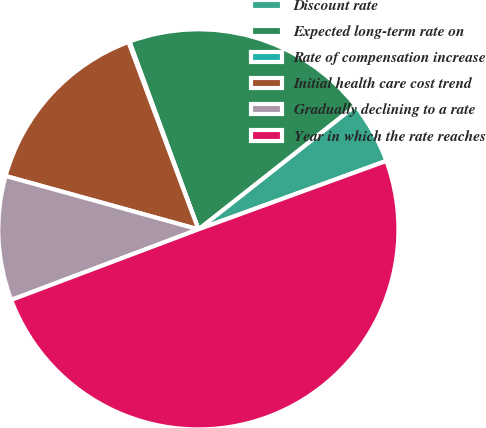Convert chart to OTSL. <chart><loc_0><loc_0><loc_500><loc_500><pie_chart><fcel>Discount rate<fcel>Expected long-term rate on<fcel>Rate of compensation increase<fcel>Initial health care cost trend<fcel>Gradually declining to a rate<fcel>Year in which the rate reaches<nl><fcel>5.06%<fcel>19.98%<fcel>0.09%<fcel>15.01%<fcel>10.04%<fcel>49.82%<nl></chart> 